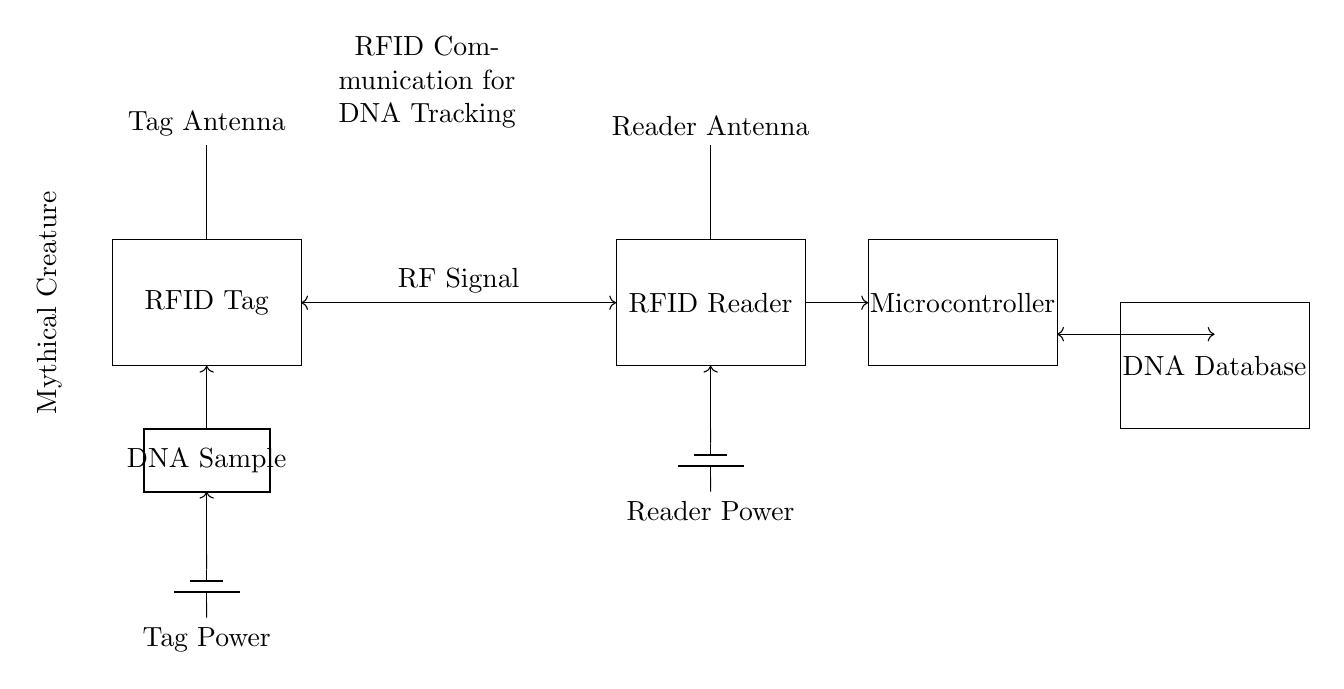What type of circuit is represented? The circuit represents a communication circuit utilized for RFID tracking purposes. It includes components designed to facilitate the transmission and reception of radio frequency signals for tracking DNA samples.
Answer: RFID tracking circuit What is the function of the tag antenna? The tag antenna is responsible for transmitting and receiving RF signals to and from the RFID reader, enabling the communication necessary for identifying and tracking the mythical creature DNA samples.
Answer: Communication How many main components are in the circuit? The circuit comprises four primary components: the RFID Tag, RFID Reader, Microcontroller, and DNA Database, which work together in processing and tracking data.
Answer: Four What powers the RFID tag? The RFID tag is powered by a battery source located below it, specifically indicated in the circuit diagram, providing the necessary energy to facilitate its operation.
Answer: Tag Power What signal type is used for communication between components? The components of the circuit communicate using RF (radio frequency) signals, as indicated in the connection between the RFID tag and the RFID reader.
Answer: RF Signal Why is a microcontroller included in the circuit? The microcontroller processes data received from the RFID reader, manages communication with the DNA database, and controls operations for efficient data tracking of mythical creature DNA samples. Thus, its presence is essential for coordinating tasks in the system.
Answer: Data management 